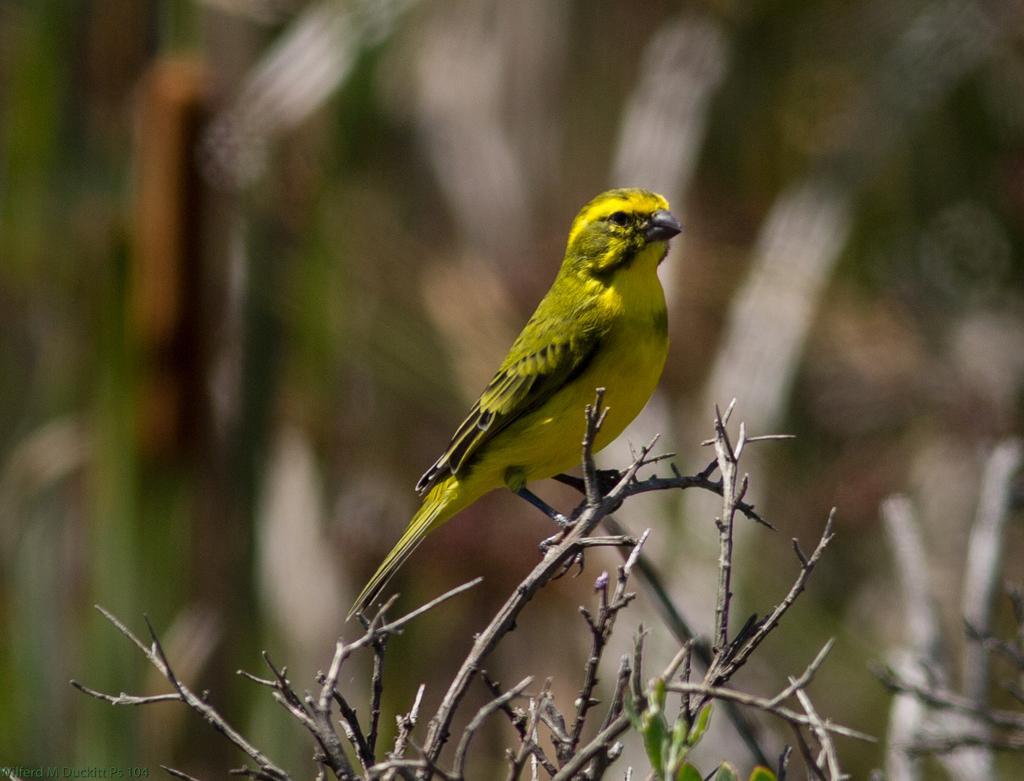How would you summarize this image in a sentence or two? This is the picture of a tree stem which has no leaves and a bird which is in yellow and green color on it. 